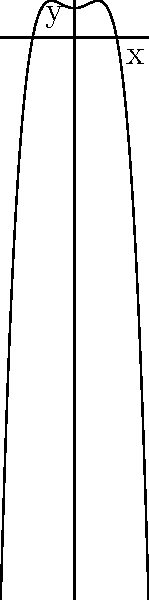A decorative ceramic plate from the 18th century has a symmetrical profile that can be modeled by the polynomial equation $y = -0.01x^4 + 0.2x^2 + 4$, where $y$ represents the height of the plate's profile and $x$ represents the distance from the center. What is the maximum height of the plate's profile? To find the maximum height of the plate's profile, we need to follow these steps:

1) The maximum height will occur at the critical points of the function. To find these, we need to take the derivative of the function and set it equal to zero.

2) $f(x) = -0.01x^4 + 0.2x^2 + 4$
   $f'(x) = -0.04x^3 + 0.4x$

3) Set $f'(x) = 0$:
   $-0.04x^3 + 0.4x = 0$
   $x(-0.04x^2 + 0.4) = 0$

4) Solving this equation:
   $x = 0$ or $-0.04x^2 + 0.4 = 0$
   $x = 0$ or $x = \pm\sqrt{10} \approx \pm3.16$

5) These are the x-values of the critical points. To find the maximum height, we need to evaluate the original function at these points:

   $f(0) = 4$
   $f(3.16) = f(-3.16) \approx 5.16$

6) The maximum of these values is approximately 5.16.

Therefore, the maximum height of the plate's profile is approximately 5.16 units.
Answer: 5.16 units 